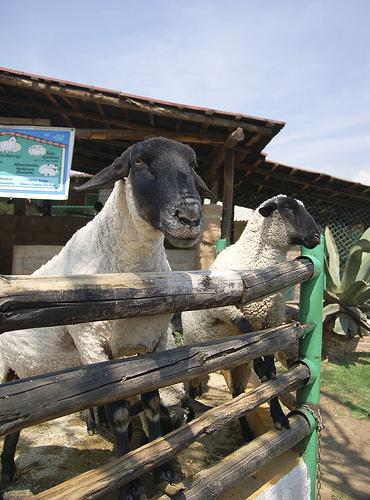Analyze the interaction between the sheep and the fence in the image. The two sheep are leaning against the wooden fence, with one sheep having its hoof resting on the railing. Can you identify the color and shape of the sheep's face and ears in the image? The sheep's face is black, and their ears are also black in color. Count the number of sheep in the image and describe their appearance. There are two sheep in the image, both having white wool with black faces and ears. What is the main object of the image, and what activity is taking place? There are two sheep in the image; they are leaning against a wooden fence in a pen. What type of landscape is featured in the image? The landscape includes a pen with two white sheep, a wooden fence, a green plant, and a clear blue sky. Provide a brief description of the fence in the image. The fence is made of wood, has some green and weathered wooden posts, and a metal chain hanging off a post. Describe the sky condition depicted in the image. The sky is clear and blue in the image. What type of plants are visible around the sheep in the image? There is a green plant with large leaves near the sheep in the image. What is unique about one of the sheep's foot placement in the image? One sheep has its hoof resting on the wooden railing of the pen. Examine the image and note any signage present within it. There is a sign posted near the roof in the image, behind the sheep. 